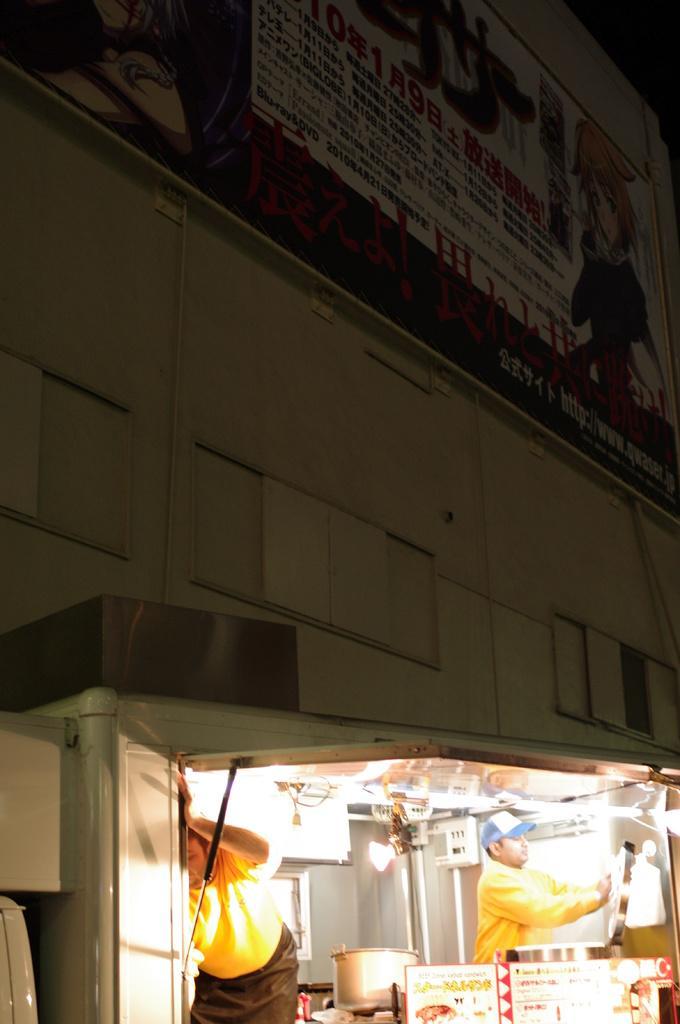Please provide a concise description of this image. In this picture we can see two people, bowl, posters, lights and some objects and in the background we can see a banner on the wall. 